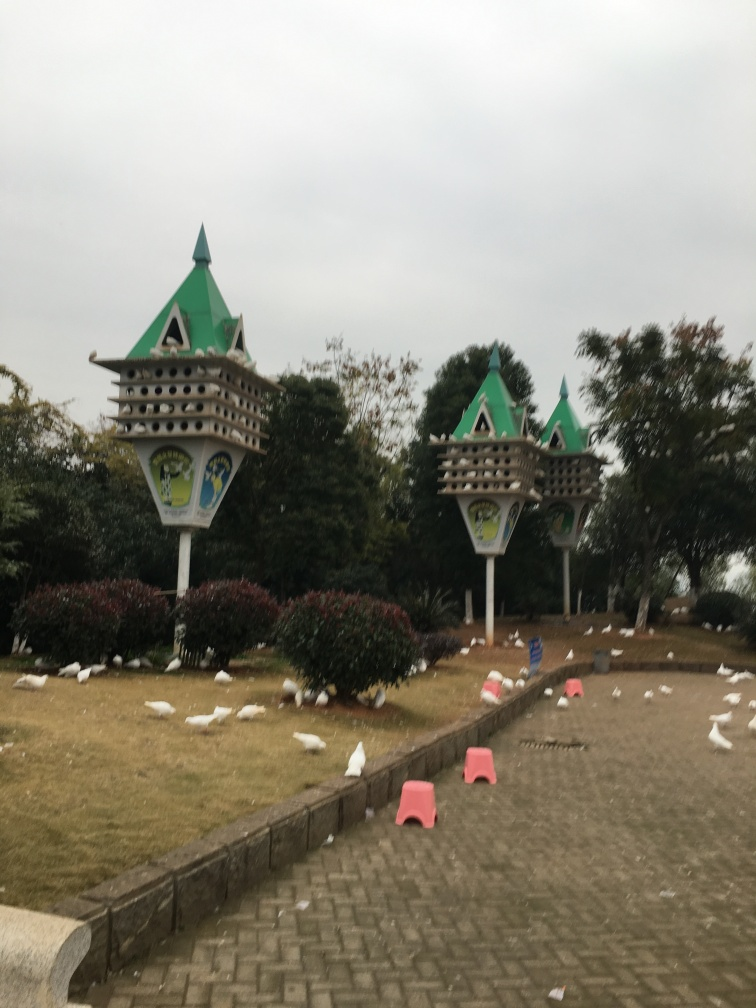What can you say about the design and aesthetics of this location? The location appears to have been designed with a theme in mind, indicated by the playful and symmetrical design of the birdhouse-like structures. The presence of manicured bushes and clean walkways suggest that aesthetic appeal and order are valued in this setting. 